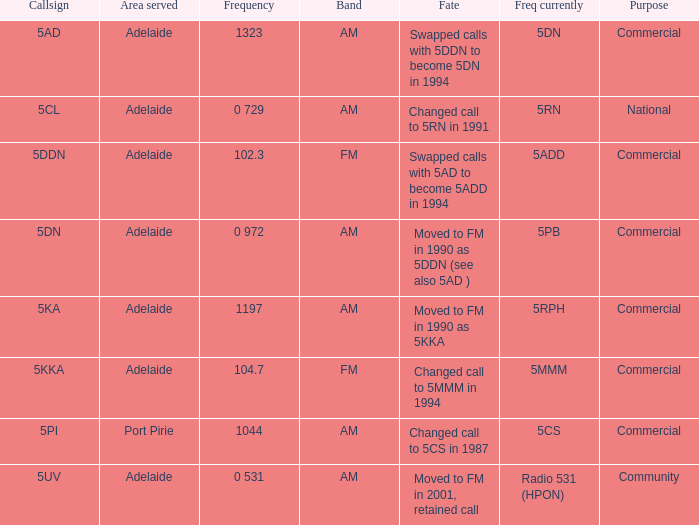What is the existing freq for frequency of 10 5MMM. 